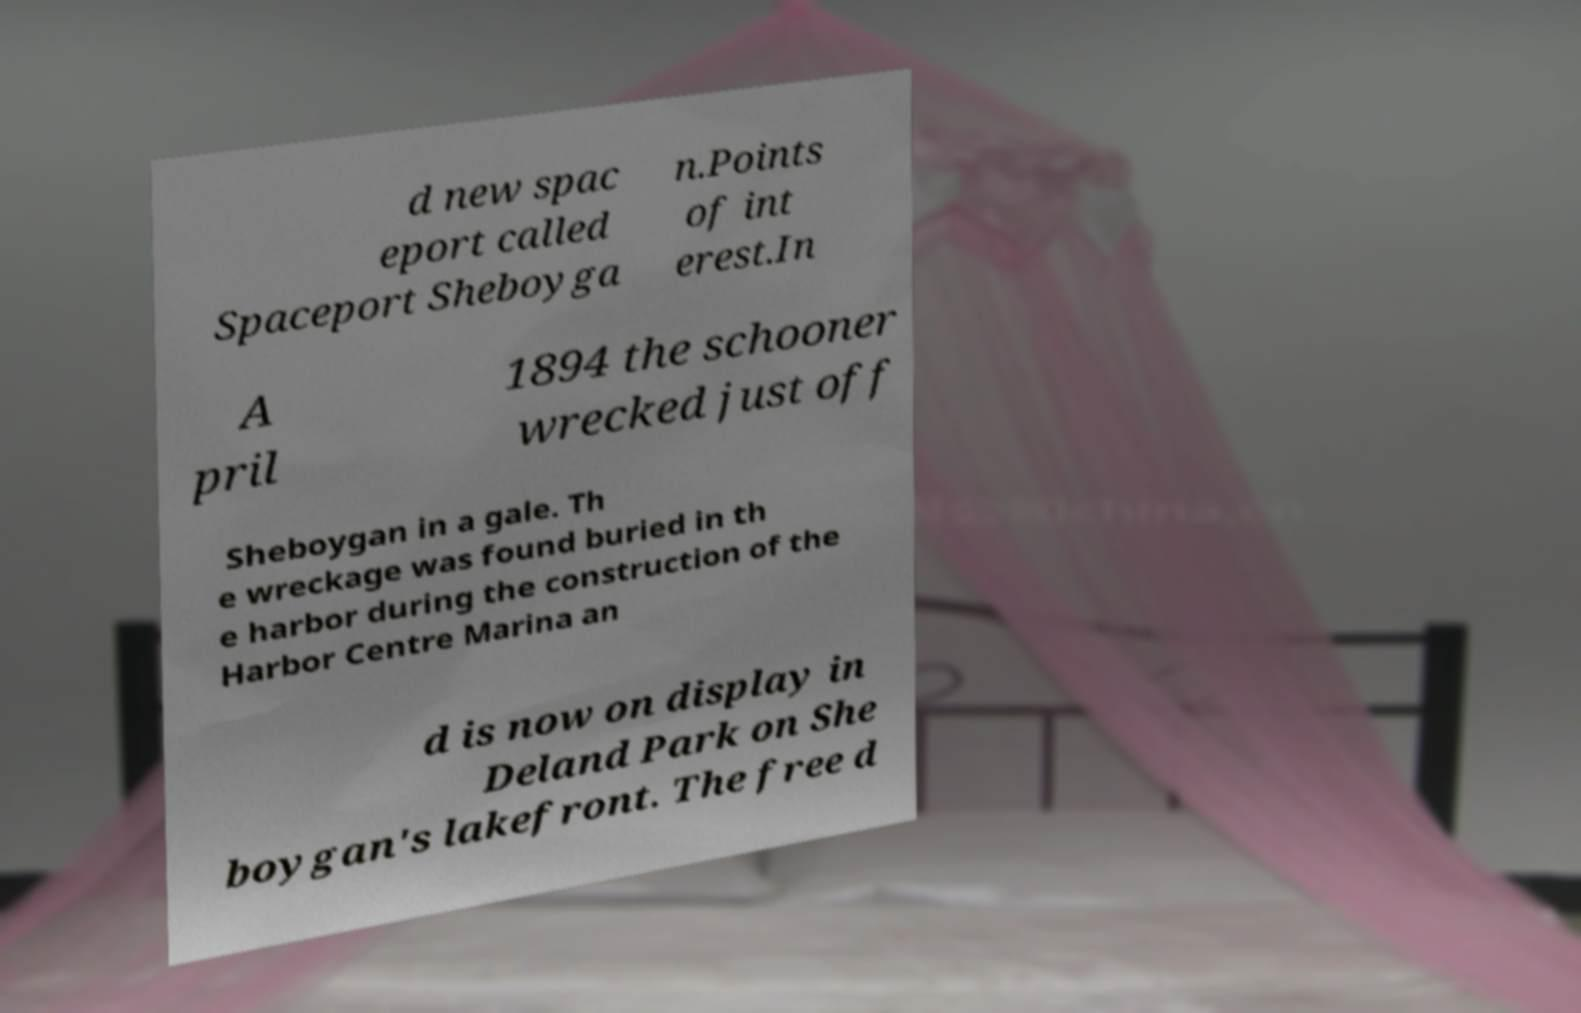Please read and relay the text visible in this image. What does it say? d new spac eport called Spaceport Sheboyga n.Points of int erest.In A pril 1894 the schooner wrecked just off Sheboygan in a gale. Th e wreckage was found buried in th e harbor during the construction of the Harbor Centre Marina an d is now on display in Deland Park on She boygan's lakefront. The free d 